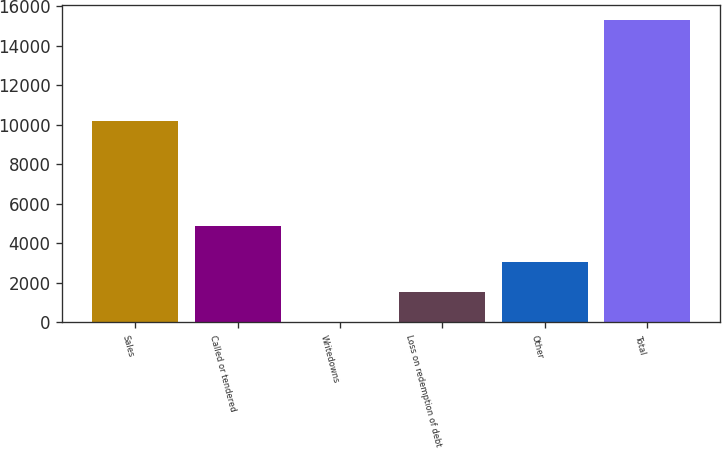Convert chart to OTSL. <chart><loc_0><loc_0><loc_500><loc_500><bar_chart><fcel>Sales<fcel>Called or tendered<fcel>Writedowns<fcel>Loss on redemption of debt<fcel>Other<fcel>Total<nl><fcel>10209<fcel>4851<fcel>2.53<fcel>1532.88<fcel>3063.23<fcel>15306<nl></chart> 